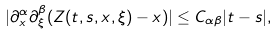Convert formula to latex. <formula><loc_0><loc_0><loc_500><loc_500>| \partial ^ { \alpha } _ { x } \partial ^ { \beta } _ { \xi } ( Z ( t , s , x , \xi ) - x ) | \leq C _ { \alpha \beta } | t - s | ,</formula> 